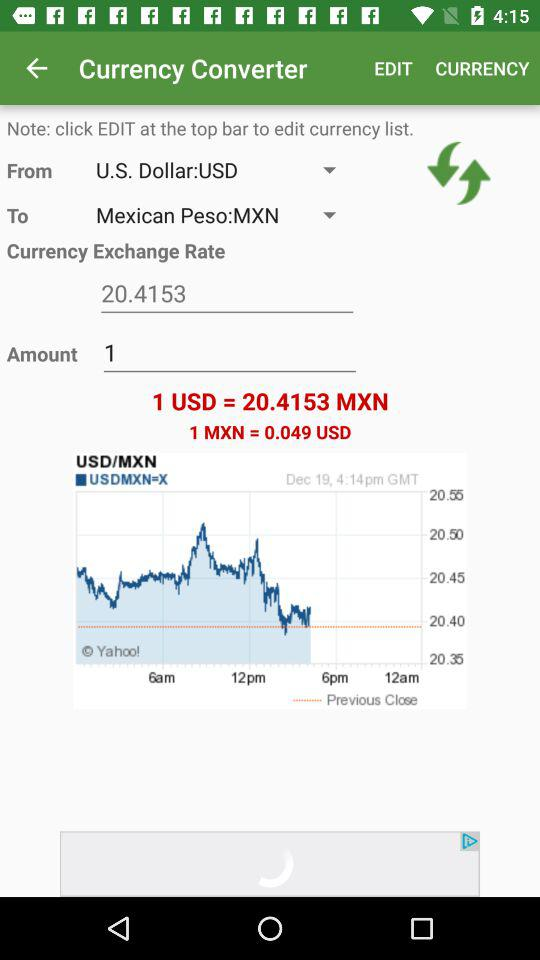What is the value of one Mexican peso in US dollars? The value of one Mexican peso in US dollars is 0.049. 